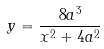<formula> <loc_0><loc_0><loc_500><loc_500>y = \frac { 8 a ^ { 3 } } { x ^ { 2 } + 4 a ^ { 2 } }</formula> 